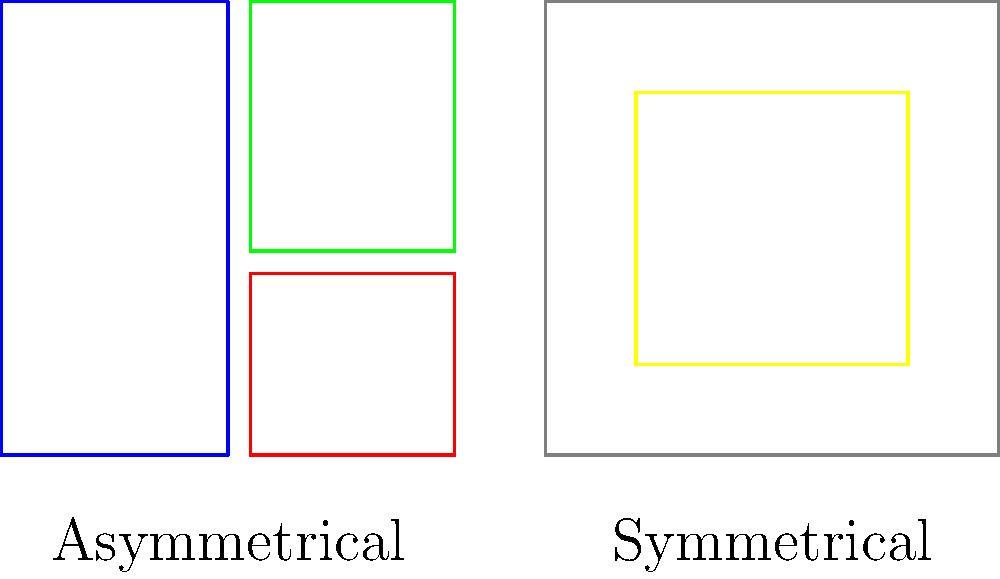As an event organizer, you're reviewing poster designs for an upcoming exhibition. Which layout technique, asymmetrical or symmetrical, would you recommend to create a more dynamic and visually interesting poster design, and why? To answer this question, let's analyze both layout techniques:

1. Asymmetrical layout:
   - Uses uneven distribution of elements
   - Creates visual tension and movement
   - Allows for more creative and unique designs
   - Can guide the viewer's eye through the composition

2. Symmetrical layout:
   - Uses balanced distribution of elements
   - Creates a sense of order and stability
   - Can be visually pleasing but may appear static
   - Works well for formal or traditional designs

3. Comparison:
   - Asymmetrical layouts are generally more dynamic and visually interesting
   - They create a sense of movement and energy
   - Asymmetry allows for more flexibility in arranging elements
   - It can better highlight key information and create a visual hierarchy

4. Application to event posters:
   - Exhibition events often benefit from eye-catching, unique designs
   - Asymmetrical layouts can help draw attention and stand out
   - They allow for creative placement of event details, images, and sponsor logos

5. Conclusion:
   - While both techniques have their merits, asymmetrical layouts are generally more suitable for creating dynamic and visually interesting poster designs for exhibition events.
Answer: Asymmetrical layout 